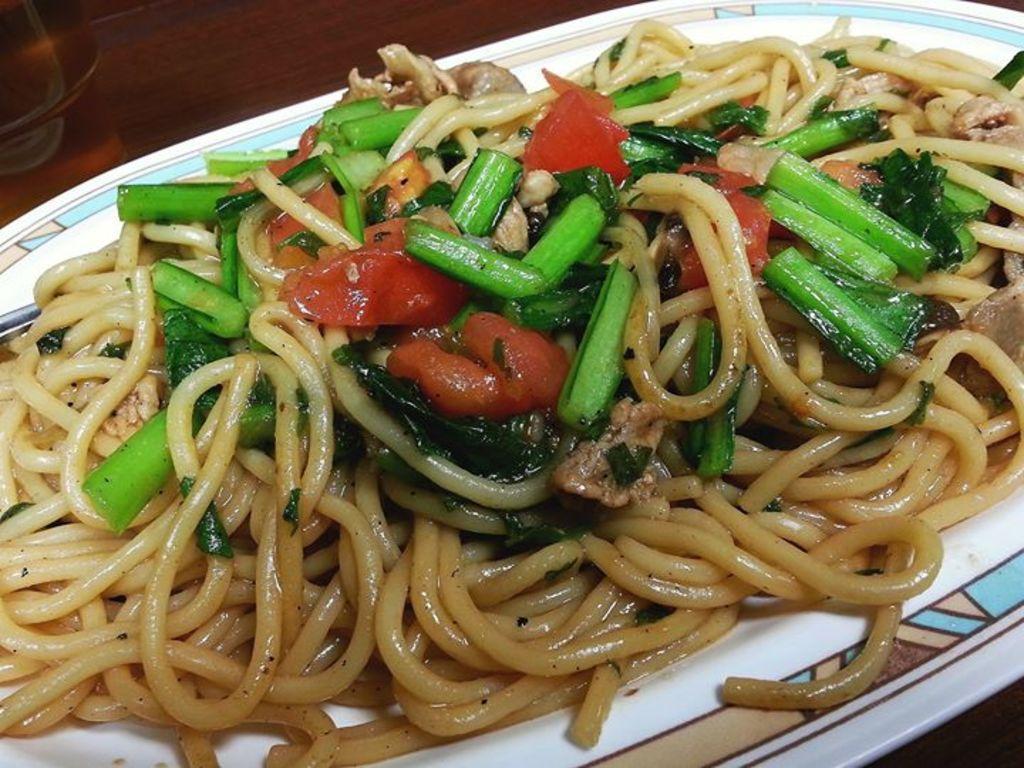Could you give a brief overview of what you see in this image? There are noodles and other food items on a plate in the center of the image, it seems like a glass in the top left side. 